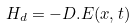Convert formula to latex. <formula><loc_0><loc_0><loc_500><loc_500>H _ { d } = - D . E ( x , t )</formula> 